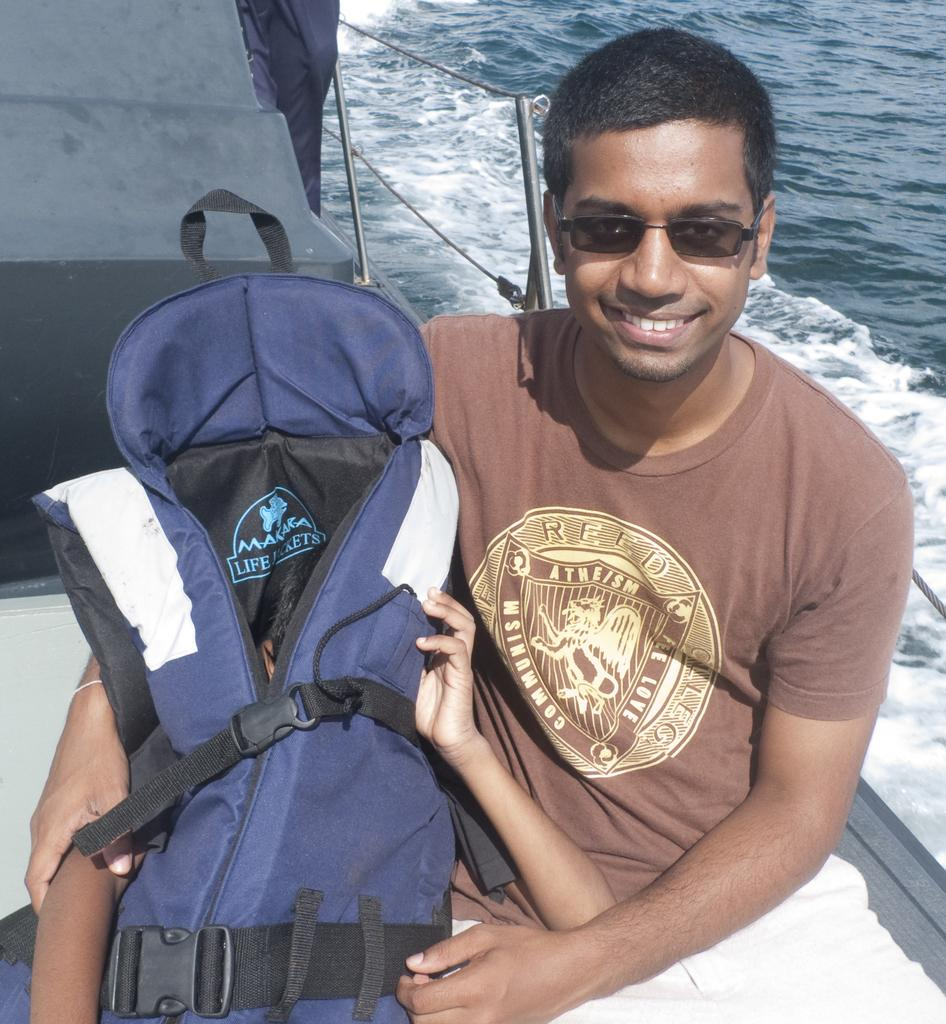Who is present in the image? There is a person in the image. What is the person doing in the image? The person is holding a boy. What mode of transportation are they using? They are riding a boat. Where is the boat located? The boat is in the water. What type of polish is the person applying to the boy's skin in the image? There is no indication in the image that the person is applying any polish to the boy's skin. 